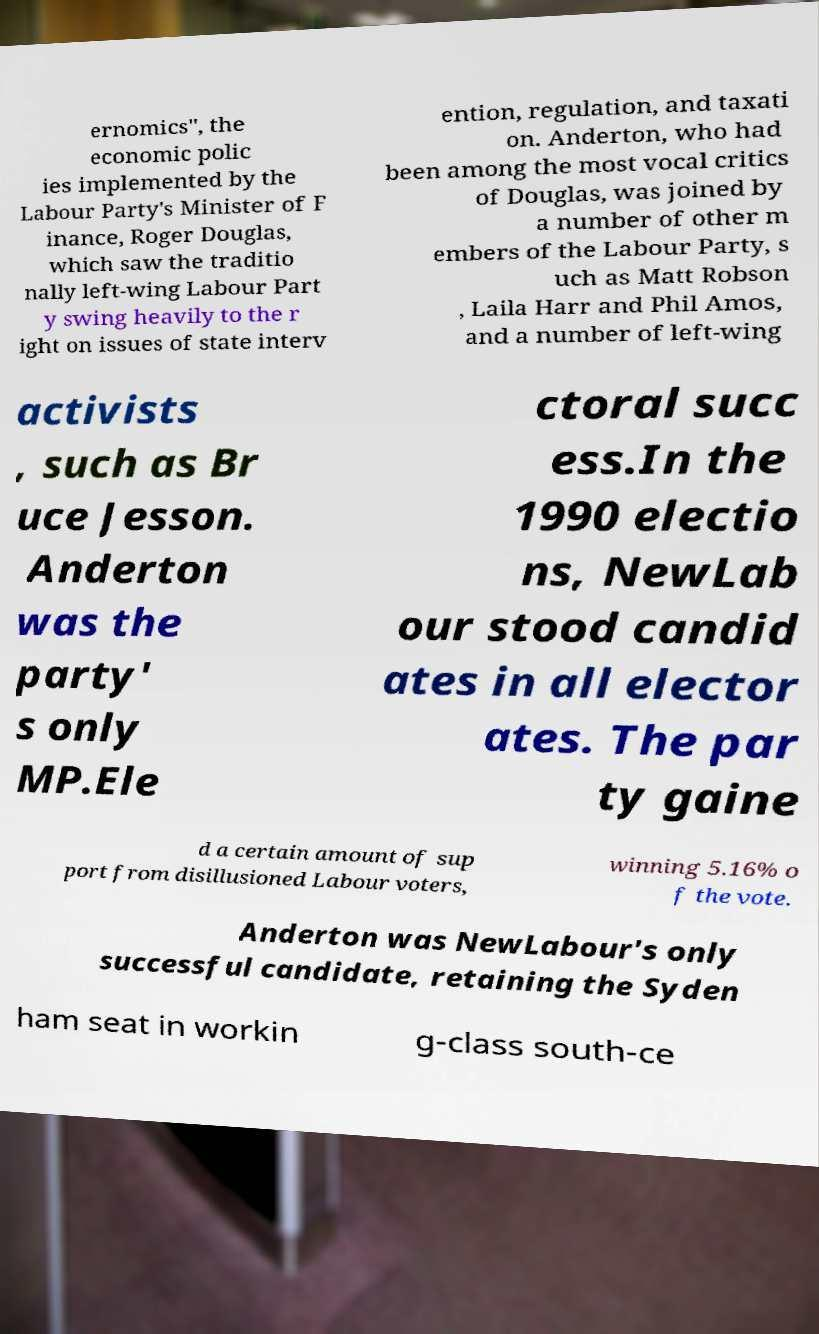Please identify and transcribe the text found in this image. ernomics", the economic polic ies implemented by the Labour Party's Minister of F inance, Roger Douglas, which saw the traditio nally left-wing Labour Part y swing heavily to the r ight on issues of state interv ention, regulation, and taxati on. Anderton, who had been among the most vocal critics of Douglas, was joined by a number of other m embers of the Labour Party, s uch as Matt Robson , Laila Harr and Phil Amos, and a number of left-wing activists , such as Br uce Jesson. Anderton was the party' s only MP.Ele ctoral succ ess.In the 1990 electio ns, NewLab our stood candid ates in all elector ates. The par ty gaine d a certain amount of sup port from disillusioned Labour voters, winning 5.16% o f the vote. Anderton was NewLabour's only successful candidate, retaining the Syden ham seat in workin g-class south-ce 